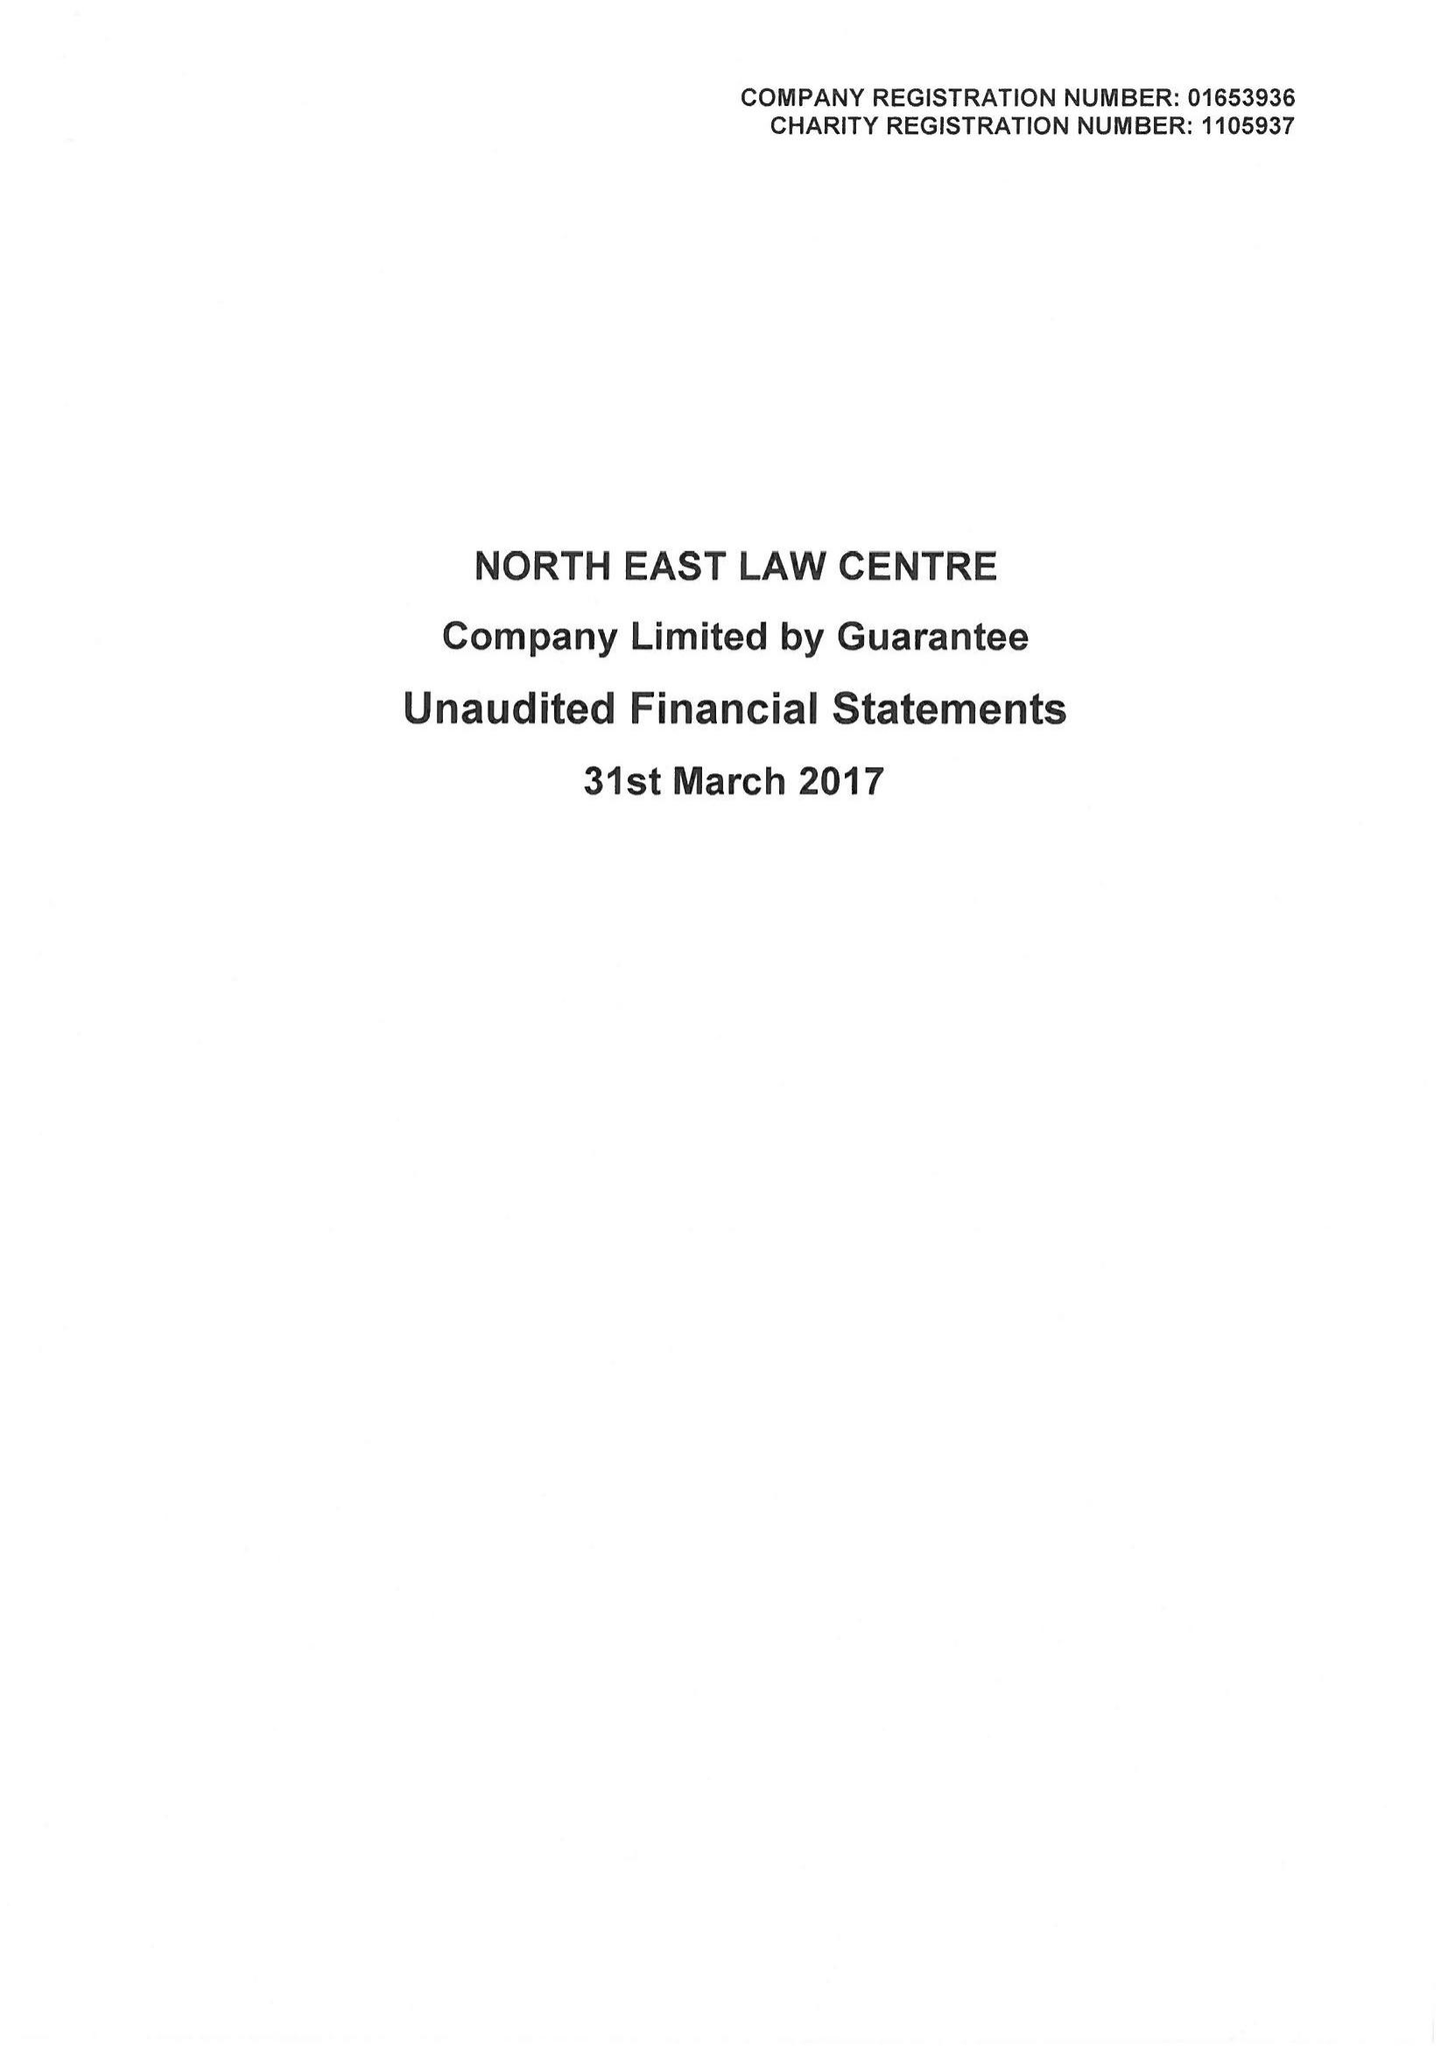What is the value for the charity_number?
Answer the question using a single word or phrase. 1105937 